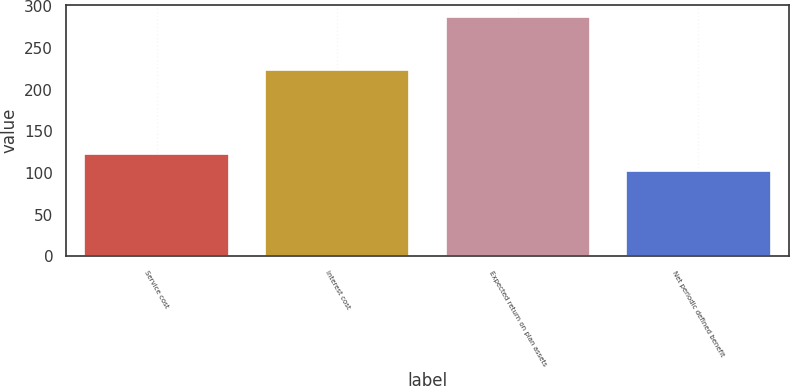Convert chart to OTSL. <chart><loc_0><loc_0><loc_500><loc_500><bar_chart><fcel>Service cost<fcel>Interest cost<fcel>Expected return on plan assets<fcel>Net periodic defined benefit<nl><fcel>123<fcel>224<fcel>287<fcel>102.5<nl></chart> 